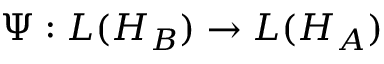<formula> <loc_0><loc_0><loc_500><loc_500>\Psi \colon L ( H _ { B } ) \rightarrow L ( H _ { A } )</formula> 